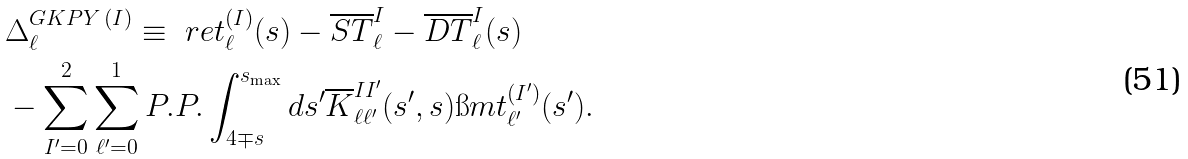<formula> <loc_0><loc_0><loc_500><loc_500>& \Delta _ { \ell } ^ { G K P Y \, ( I ) } \equiv \ r e t _ { \ell } ^ { ( I ) } ( s ) - \overline { S T } _ { \ell } ^ { I } - \overline { D T } ^ { I } _ { \ell } ( s ) \\ & - \sum _ { I ^ { \prime } = 0 } ^ { 2 } \sum _ { \ell ^ { \prime } = 0 } ^ { 1 } P . P . \int _ { 4 \mp s } ^ { s _ { \max } } d s ^ { \prime } \overline { K } _ { \ell \ell ^ { \prime } } ^ { I I ^ { \prime } } ( s ^ { \prime } , s ) \i m t _ { \ell ^ { \prime } } ^ { ( I ^ { \prime } ) } ( s ^ { \prime } ) .</formula> 